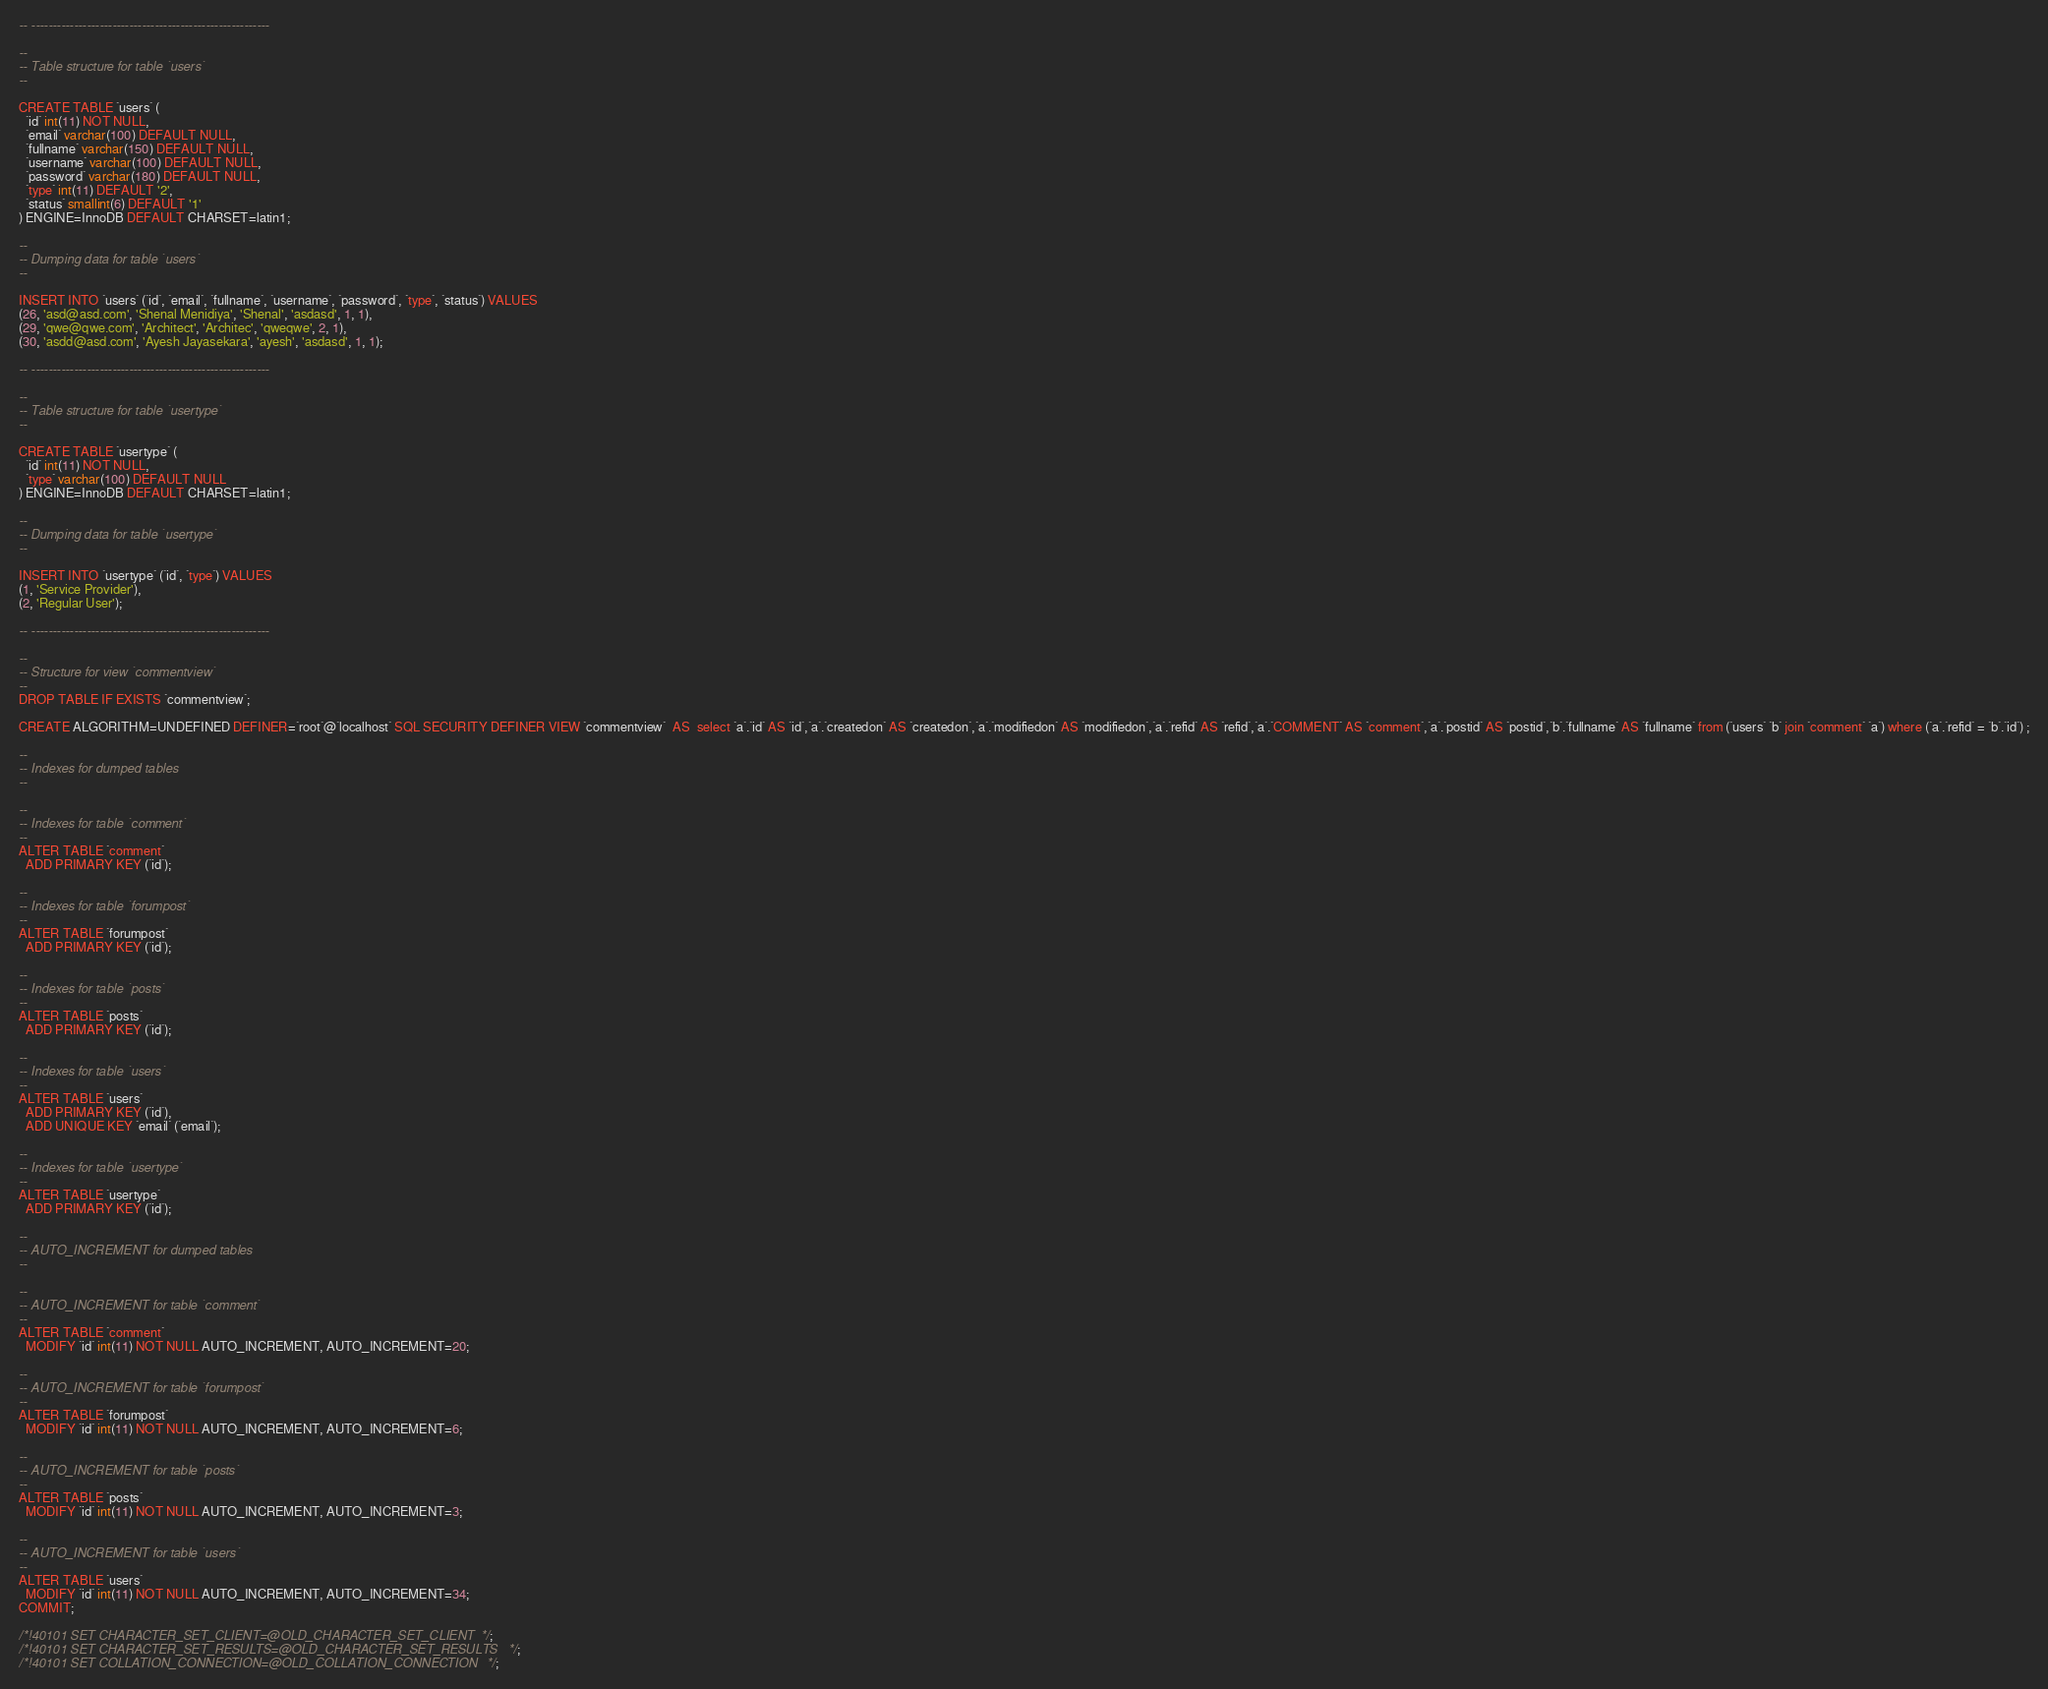Convert code to text. <code><loc_0><loc_0><loc_500><loc_500><_SQL_>-- --------------------------------------------------------

--
-- Table structure for table `users`
--

CREATE TABLE `users` (
  `id` int(11) NOT NULL,
  `email` varchar(100) DEFAULT NULL,
  `fullname` varchar(150) DEFAULT NULL,
  `username` varchar(100) DEFAULT NULL,
  `password` varchar(180) DEFAULT NULL,
  `type` int(11) DEFAULT '2',
  `status` smallint(6) DEFAULT '1'
) ENGINE=InnoDB DEFAULT CHARSET=latin1;

--
-- Dumping data for table `users`
--

INSERT INTO `users` (`id`, `email`, `fullname`, `username`, `password`, `type`, `status`) VALUES
(26, 'asd@asd.com', 'Shenal Menidiya', 'Shenal', 'asdasd', 1, 1),
(29, 'qwe@qwe.com', 'Architect', 'Architec', 'qweqwe', 2, 1),
(30, 'asdd@asd.com', 'Ayesh Jayasekara', 'ayesh', 'asdasd', 1, 1);

-- --------------------------------------------------------

--
-- Table structure for table `usertype`
--

CREATE TABLE `usertype` (
  `id` int(11) NOT NULL,
  `type` varchar(100) DEFAULT NULL
) ENGINE=InnoDB DEFAULT CHARSET=latin1;

--
-- Dumping data for table `usertype`
--

INSERT INTO `usertype` (`id`, `type`) VALUES
(1, 'Service Provider'),
(2, 'Regular User');

-- --------------------------------------------------------

--
-- Structure for view `commentview`
--
DROP TABLE IF EXISTS `commentview`;

CREATE ALGORITHM=UNDEFINED DEFINER=`root`@`localhost` SQL SECURITY DEFINER VIEW `commentview`  AS  select `a`.`id` AS `id`,`a`.`createdon` AS `createdon`,`a`.`modifiedon` AS `modifiedon`,`a`.`refid` AS `refid`,`a`.`COMMENT` AS `comment`,`a`.`postid` AS `postid`,`b`.`fullname` AS `fullname` from (`users` `b` join `comment` `a`) where (`a`.`refid` = `b`.`id`) ;

--
-- Indexes for dumped tables
--

--
-- Indexes for table `comment`
--
ALTER TABLE `comment`
  ADD PRIMARY KEY (`id`);

--
-- Indexes for table `forumpost`
--
ALTER TABLE `forumpost`
  ADD PRIMARY KEY (`id`);

--
-- Indexes for table `posts`
--
ALTER TABLE `posts`
  ADD PRIMARY KEY (`id`);

--
-- Indexes for table `users`
--
ALTER TABLE `users`
  ADD PRIMARY KEY (`id`),
  ADD UNIQUE KEY `email` (`email`);

--
-- Indexes for table `usertype`
--
ALTER TABLE `usertype`
  ADD PRIMARY KEY (`id`);

--
-- AUTO_INCREMENT for dumped tables
--

--
-- AUTO_INCREMENT for table `comment`
--
ALTER TABLE `comment`
  MODIFY `id` int(11) NOT NULL AUTO_INCREMENT, AUTO_INCREMENT=20;

--
-- AUTO_INCREMENT for table `forumpost`
--
ALTER TABLE `forumpost`
  MODIFY `id` int(11) NOT NULL AUTO_INCREMENT, AUTO_INCREMENT=6;

--
-- AUTO_INCREMENT for table `posts`
--
ALTER TABLE `posts`
  MODIFY `id` int(11) NOT NULL AUTO_INCREMENT, AUTO_INCREMENT=3;

--
-- AUTO_INCREMENT for table `users`
--
ALTER TABLE `users`
  MODIFY `id` int(11) NOT NULL AUTO_INCREMENT, AUTO_INCREMENT=34;
COMMIT;

/*!40101 SET CHARACTER_SET_CLIENT=@OLD_CHARACTER_SET_CLIENT */;
/*!40101 SET CHARACTER_SET_RESULTS=@OLD_CHARACTER_SET_RESULTS */;
/*!40101 SET COLLATION_CONNECTION=@OLD_COLLATION_CONNECTION */;
</code> 